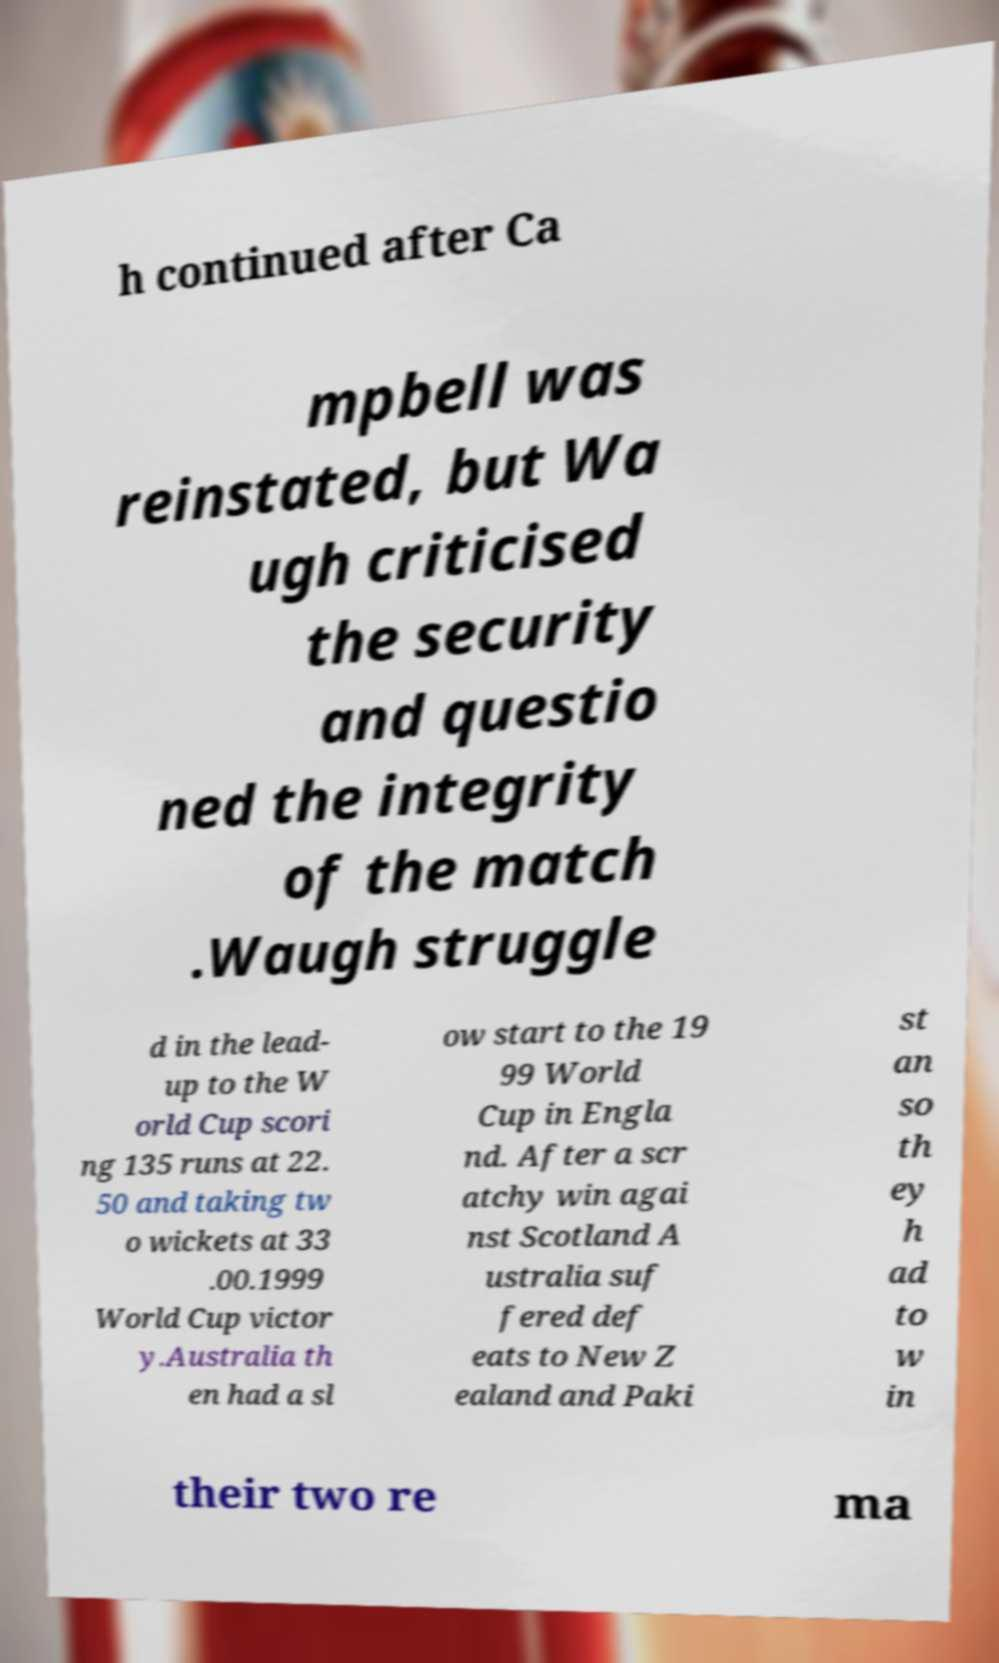What messages or text are displayed in this image? I need them in a readable, typed format. h continued after Ca mpbell was reinstated, but Wa ugh criticised the security and questio ned the integrity of the match .Waugh struggle d in the lead- up to the W orld Cup scori ng 135 runs at 22. 50 and taking tw o wickets at 33 .00.1999 World Cup victor y.Australia th en had a sl ow start to the 19 99 World Cup in Engla nd. After a scr atchy win agai nst Scotland A ustralia suf fered def eats to New Z ealand and Paki st an so th ey h ad to w in their two re ma 